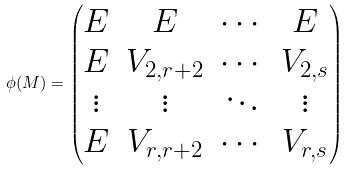<formula> <loc_0><loc_0><loc_500><loc_500>\phi ( M ) = \begin{pmatrix} E & E & \cdots & E \\ E & V _ { 2 , r + 2 } & \cdots & V _ { 2 , s } \\ \vdots & \vdots & \ddots & \vdots \\ E & V _ { r , r + 2 } & \cdots & V _ { r , s } \end{pmatrix}</formula> 